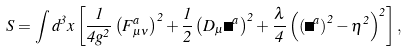Convert formula to latex. <formula><loc_0><loc_0><loc_500><loc_500>S = \int d ^ { 3 } x \left [ \frac { 1 } { 4 g ^ { 2 } } \left ( F _ { \mu \nu } ^ { a } \right ) ^ { 2 } + \frac { 1 } { 2 } \left ( D _ { \mu } \Phi ^ { a } \right ) ^ { 2 } + \frac { \lambda } { 4 } \left ( \left ( \Phi ^ { a } \right ) ^ { 2 } - \eta ^ { 2 } \right ) ^ { 2 } \right ] ,</formula> 